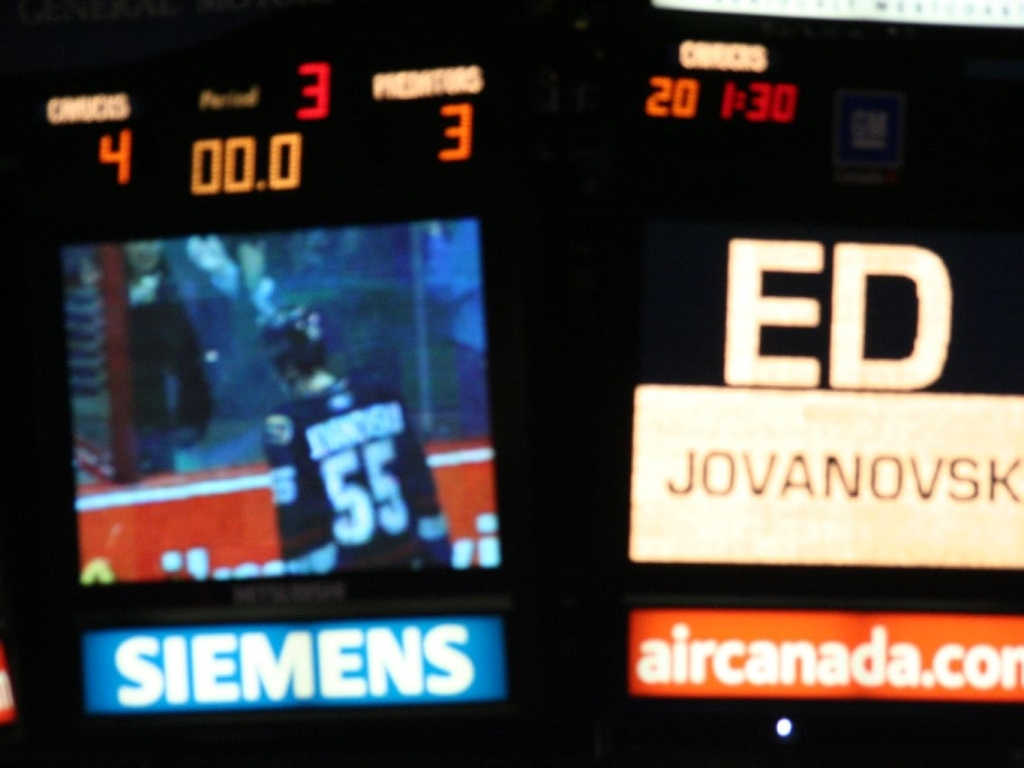Can you tell what event is taking place in this picture? The image shows a scoreboard from what appears to be an ice hockey game, given the player visible and references to 'period' and time. It captures the moment right after a period of play has ended with one team in the lead. The scoreboard provides some context to the event, but the quality of the image makes it difficult to extract further details. 